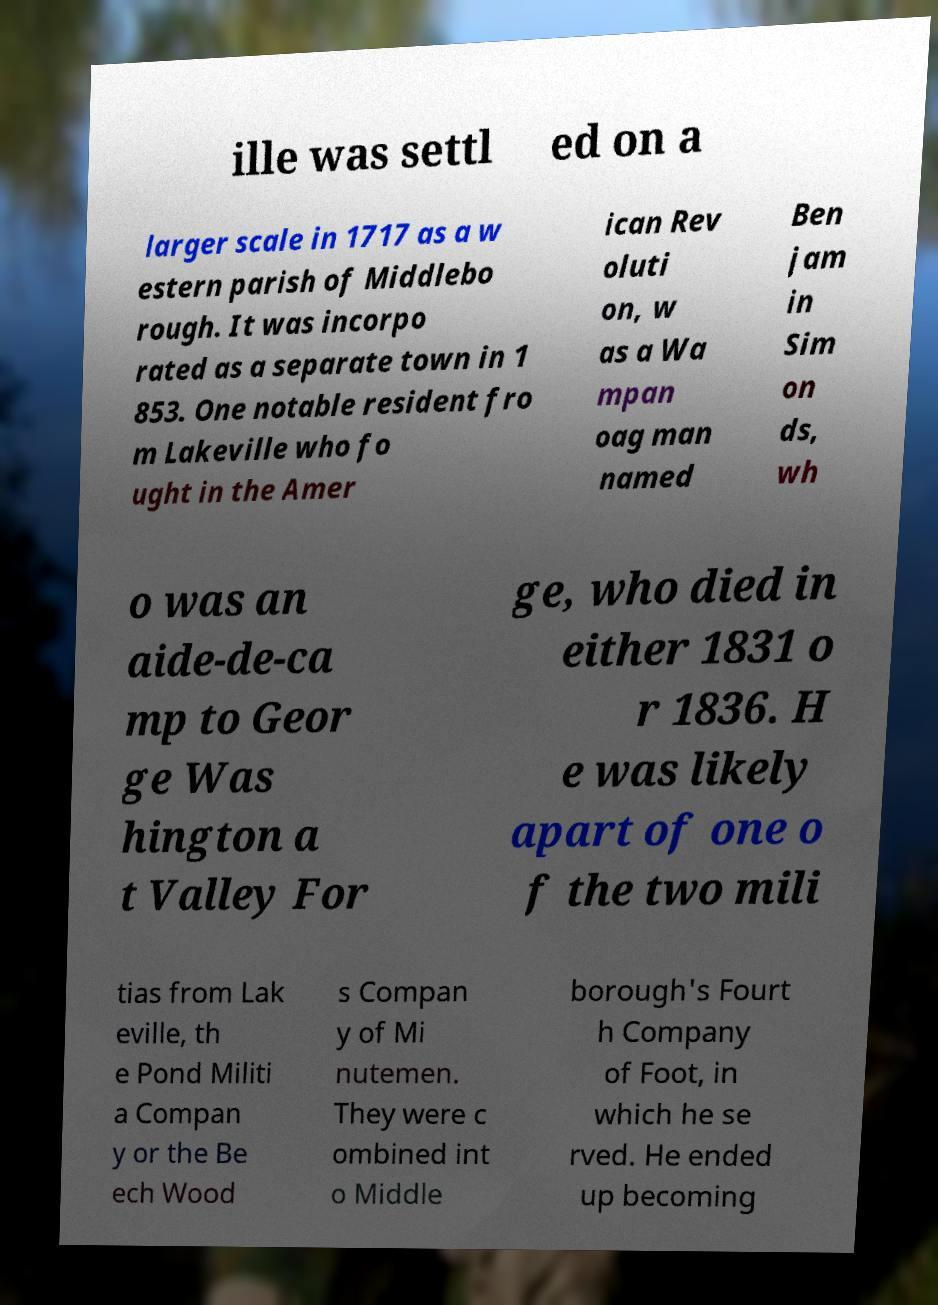Please identify and transcribe the text found in this image. ille was settl ed on a larger scale in 1717 as a w estern parish of Middlebo rough. It was incorpo rated as a separate town in 1 853. One notable resident fro m Lakeville who fo ught in the Amer ican Rev oluti on, w as a Wa mpan oag man named Ben jam in Sim on ds, wh o was an aide-de-ca mp to Geor ge Was hington a t Valley For ge, who died in either 1831 o r 1836. H e was likely apart of one o f the two mili tias from Lak eville, th e Pond Militi a Compan y or the Be ech Wood s Compan y of Mi nutemen. They were c ombined int o Middle borough's Fourt h Company of Foot, in which he se rved. He ended up becoming 